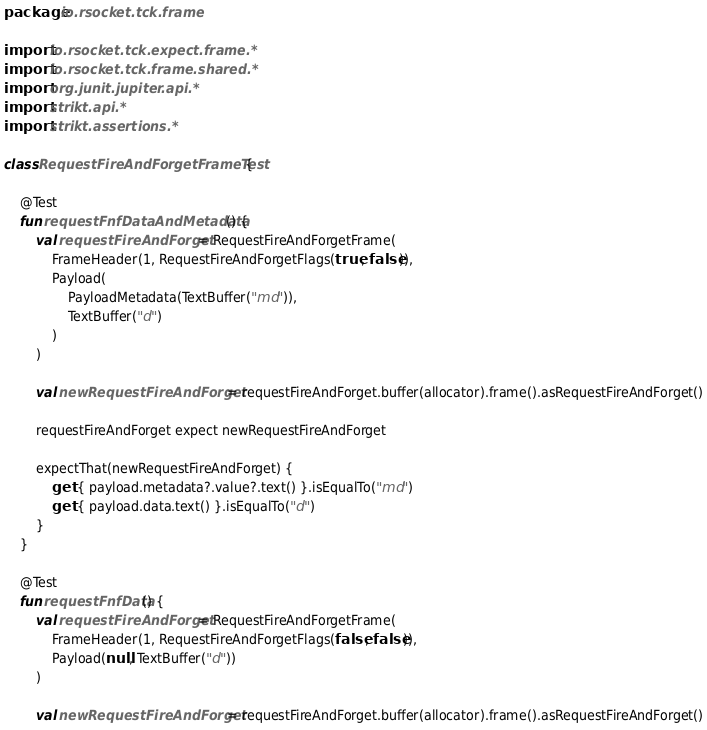Convert code to text. <code><loc_0><loc_0><loc_500><loc_500><_Kotlin_>package io.rsocket.tck.frame

import io.rsocket.tck.expect.frame.*
import io.rsocket.tck.frame.shared.*
import org.junit.jupiter.api.*
import strikt.api.*
import strikt.assertions.*

class RequestFireAndForgetFrameTest {

    @Test
    fun requestFnfDataAndMetadata() {
        val requestFireAndForget = RequestFireAndForgetFrame(
            FrameHeader(1, RequestFireAndForgetFlags(true, false)),
            Payload(
                PayloadMetadata(TextBuffer("md")),
                TextBuffer("d")
            )
        )

        val newRequestFireAndForget = requestFireAndForget.buffer(allocator).frame().asRequestFireAndForget()

        requestFireAndForget expect newRequestFireAndForget

        expectThat(newRequestFireAndForget) {
            get { payload.metadata?.value?.text() }.isEqualTo("md")
            get { payload.data.text() }.isEqualTo("d")
        }
    }

    @Test
    fun requestFnfData() {
        val requestFireAndForget = RequestFireAndForgetFrame(
            FrameHeader(1, RequestFireAndForgetFlags(false, false)),
            Payload(null, TextBuffer("d"))
        )

        val newRequestFireAndForget = requestFireAndForget.buffer(allocator).frame().asRequestFireAndForget()
</code> 